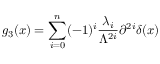<formula> <loc_0><loc_0><loc_500><loc_500>g _ { 3 } ( x ) = \sum _ { i = 0 } ^ { n } ( - 1 ) ^ { i } \frac { \lambda _ { i } } { \Lambda ^ { 2 i } } \partial ^ { 2 i } \delta ( x ) \,</formula> 